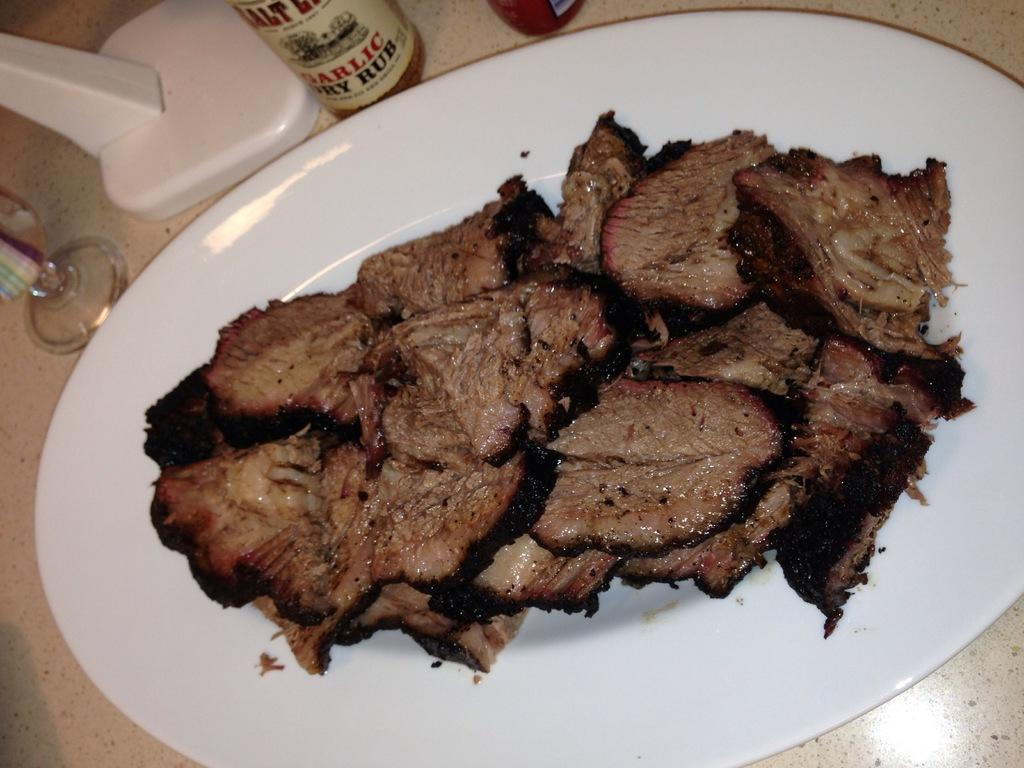<image>
Create a compact narrative representing the image presented. Cut up steak next to a bottle of garlic rub 